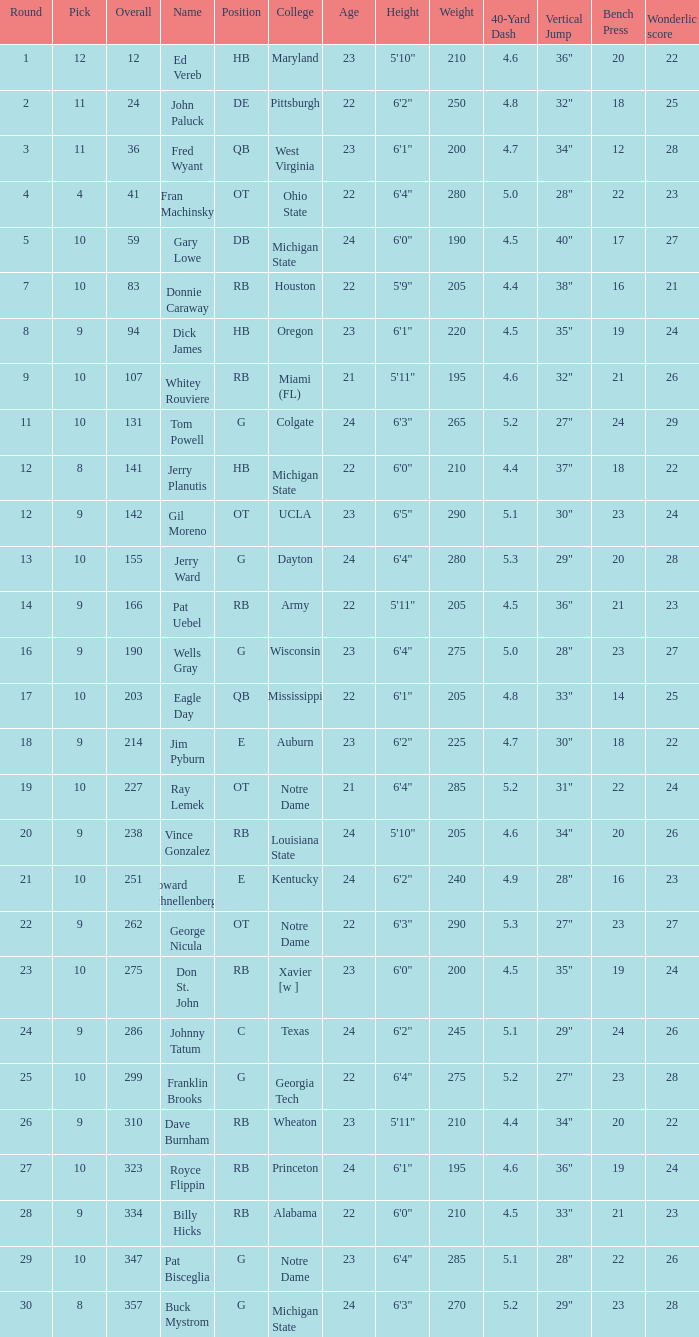What is the average number of rounds for billy hicks who had an overall pick number bigger than 310? 28.0. I'm looking to parse the entire table for insights. Could you assist me with that? {'header': ['Round', 'Pick', 'Overall', 'Name', 'Position', 'College', 'Age', 'Height', 'Weight', '40-Yard Dash', 'Vertical Jump', 'Bench Press', 'Wonderlic score'], 'rows': [['1', '12', '12', 'Ed Vereb', 'HB', 'Maryland', '23', '5\'10"', '210', '4.6', '36"', '20', '22'], ['2', '11', '24', 'John Paluck', 'DE', 'Pittsburgh', '22', '6\'2"', '250', '4.8', '32"', '18', '25'], ['3', '11', '36', 'Fred Wyant', 'QB', 'West Virginia', '23', '6\'1"', '200', '4.7', '34"', '12', '28'], ['4', '4', '41', 'Fran Machinsky', 'OT', 'Ohio State', '22', '6\'4"', '280', '5.0', '28"', '22', '23'], ['5', '10', '59', 'Gary Lowe', 'DB', 'Michigan State', '24', '6\'0"', '190', '4.5', '40"', '17', '27'], ['7', '10', '83', 'Donnie Caraway', 'RB', 'Houston', '22', '5\'9"', '205', '4.4', '38"', '16', '21'], ['8', '9', '94', 'Dick James', 'HB', 'Oregon', '23', '6\'1"', '220', '4.5', '35"', '19', '24'], ['9', '10', '107', 'Whitey Rouviere', 'RB', 'Miami (FL)', '21', '5\'11"', '195', '4.6', '32"', '21', '26'], ['11', '10', '131', 'Tom Powell', 'G', 'Colgate', '24', '6\'3"', '265', '5.2', '27"', '24', '29'], ['12', '8', '141', 'Jerry Planutis', 'HB', 'Michigan State', '22', '6\'0"', '210', '4.4', '37"', '18', '22'], ['12', '9', '142', 'Gil Moreno', 'OT', 'UCLA', '23', '6\'5"', '290', '5.1', '30"', '23', '24'], ['13', '10', '155', 'Jerry Ward', 'G', 'Dayton', '24', '6\'4"', '280', '5.3', '29"', '20', '28'], ['14', '9', '166', 'Pat Uebel', 'RB', 'Army', '22', '5\'11"', '205', '4.5', '36"', '21', '23'], ['16', '9', '190', 'Wells Gray', 'G', 'Wisconsin', '23', '6\'4"', '275', '5.0', '28"', '23', '27'], ['17', '10', '203', 'Eagle Day', 'QB', 'Mississippi', '22', '6\'1"', '205', '4.8', '33"', '14', '25'], ['18', '9', '214', 'Jim Pyburn', 'E', 'Auburn', '23', '6\'2"', '225', '4.7', '30"', '18', '22'], ['19', '10', '227', 'Ray Lemek', 'OT', 'Notre Dame', '21', '6\'4"', '285', '5.2', '31"', '22', '24'], ['20', '9', '238', 'Vince Gonzalez', 'RB', 'Louisiana State', '24', '5\'10"', '205', '4.6', '34"', '20', '26'], ['21', '10', '251', 'Howard Schnellenberger', 'E', 'Kentucky', '24', '6\'2"', '240', '4.9', '28"', '16', '23'], ['22', '9', '262', 'George Nicula', 'OT', 'Notre Dame', '22', '6\'3"', '290', '5.3', '27"', '23', '27'], ['23', '10', '275', 'Don St. John', 'RB', 'Xavier [w ]', '23', '6\'0"', '200', '4.5', '35"', '19', '24'], ['24', '9', '286', 'Johnny Tatum', 'C', 'Texas', '24', '6\'2"', '245', '5.1', '29"', '24', '26'], ['25', '10', '299', 'Franklin Brooks', 'G', 'Georgia Tech', '22', '6\'4"', '275', '5.2', '27"', '23', '28'], ['26', '9', '310', 'Dave Burnham', 'RB', 'Wheaton', '23', '5\'11"', '210', '4.4', '34"', '20', '22'], ['27', '10', '323', 'Royce Flippin', 'RB', 'Princeton', '24', '6\'1"', '195', '4.6', '36"', '19', '24'], ['28', '9', '334', 'Billy Hicks', 'RB', 'Alabama', '22', '6\'0"', '210', '4.5', '33"', '21', '23'], ['29', '10', '347', 'Pat Bisceglia', 'G', 'Notre Dame', '23', '6\'4"', '285', '5.1', '28"', '22', '26'], ['30', '8', '357', 'Buck Mystrom', 'G', 'Michigan State', '24', '6\'3"', '270', '5.2', '29"', '23', '28']]} 